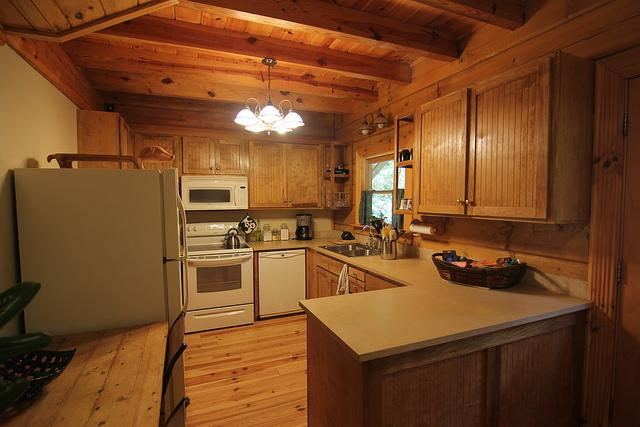What are the brightest lights attached to? ceiling 